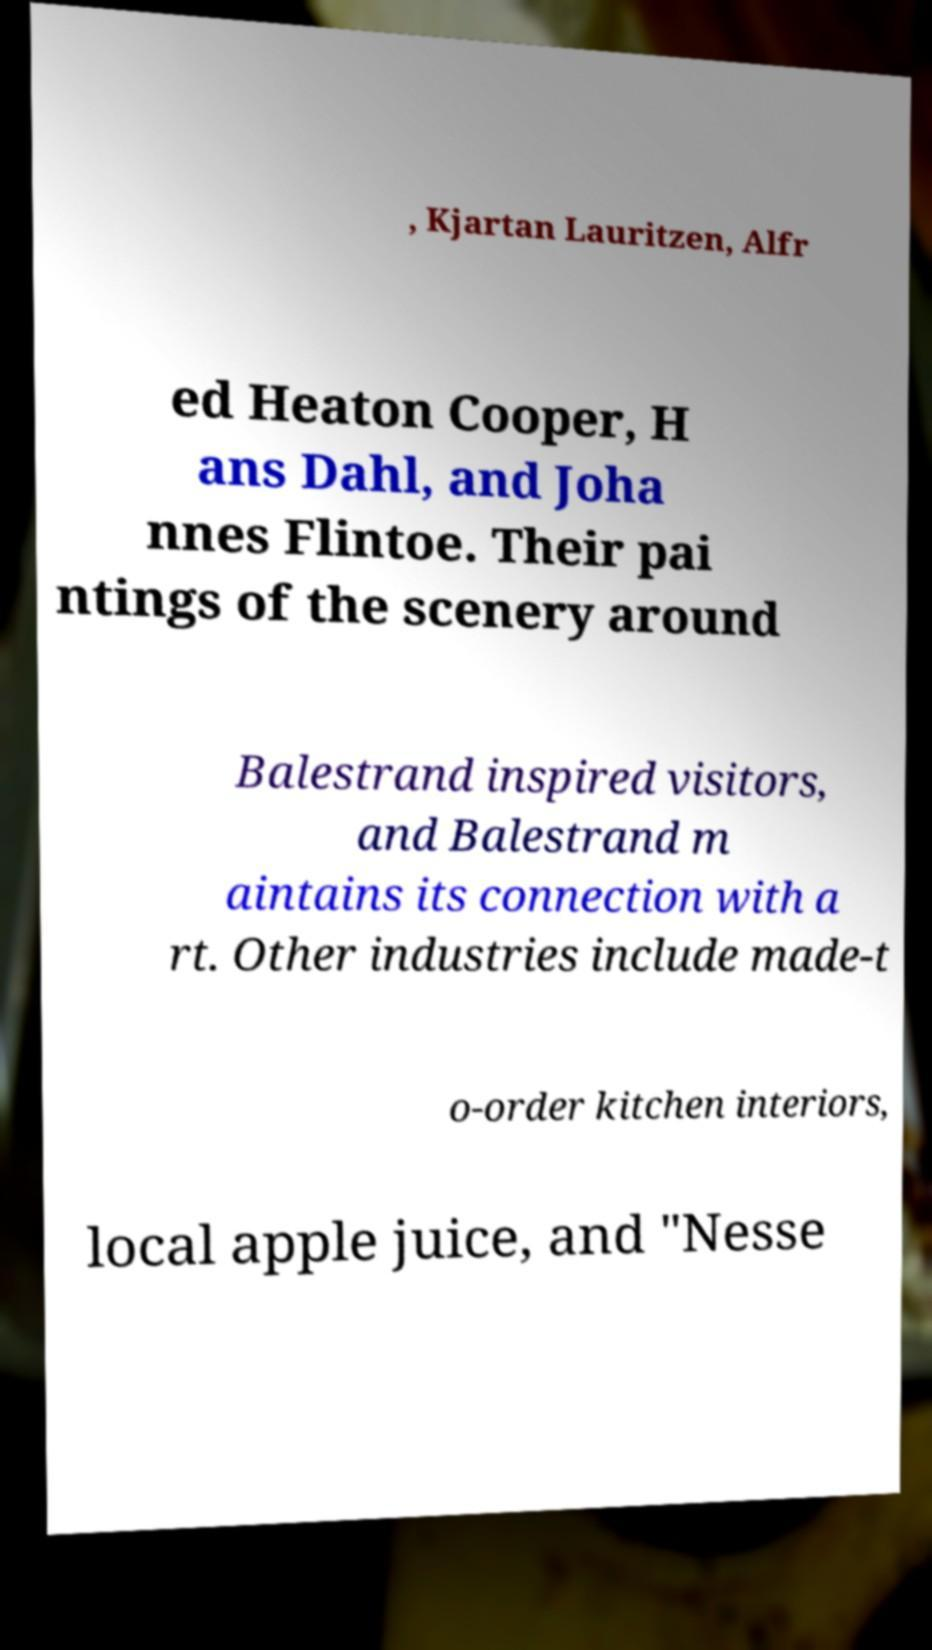Please read and relay the text visible in this image. What does it say? , Kjartan Lauritzen, Alfr ed Heaton Cooper, H ans Dahl, and Joha nnes Flintoe. Their pai ntings of the scenery around Balestrand inspired visitors, and Balestrand m aintains its connection with a rt. Other industries include made-t o-order kitchen interiors, local apple juice, and "Nesse 